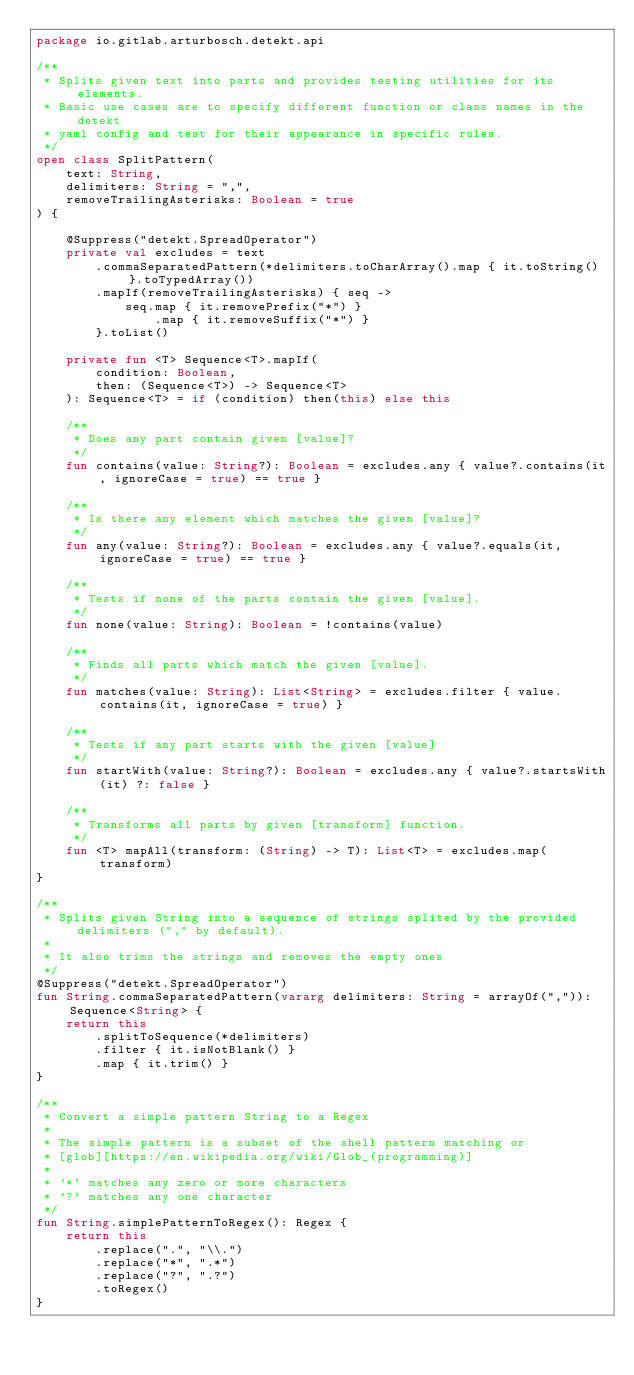Convert code to text. <code><loc_0><loc_0><loc_500><loc_500><_Kotlin_>package io.gitlab.arturbosch.detekt.api

/**
 * Splits given text into parts and provides testing utilities for its elements.
 * Basic use cases are to specify different function or class names in the detekt
 * yaml config and test for their appearance in specific rules.
 */
open class SplitPattern(
    text: String,
    delimiters: String = ",",
    removeTrailingAsterisks: Boolean = true
) {

    @Suppress("detekt.SpreadOperator")
    private val excludes = text
        .commaSeparatedPattern(*delimiters.toCharArray().map { it.toString() }.toTypedArray())
        .mapIf(removeTrailingAsterisks) { seq ->
            seq.map { it.removePrefix("*") }
                .map { it.removeSuffix("*") }
        }.toList()

    private fun <T> Sequence<T>.mapIf(
        condition: Boolean,
        then: (Sequence<T>) -> Sequence<T>
    ): Sequence<T> = if (condition) then(this) else this

    /**
     * Does any part contain given [value]?
     */
    fun contains(value: String?): Boolean = excludes.any { value?.contains(it, ignoreCase = true) == true }

    /**
     * Is there any element which matches the given [value]?
     */
    fun any(value: String?): Boolean = excludes.any { value?.equals(it, ignoreCase = true) == true }

    /**
     * Tests if none of the parts contain the given [value].
     */
    fun none(value: String): Boolean = !contains(value)

    /**
     * Finds all parts which match the given [value].
     */
    fun matches(value: String): List<String> = excludes.filter { value.contains(it, ignoreCase = true) }

    /**
     * Tests if any part starts with the given [value]
     */
    fun startWith(value: String?): Boolean = excludes.any { value?.startsWith(it) ?: false }

    /**
     * Transforms all parts by given [transform] function.
     */
    fun <T> mapAll(transform: (String) -> T): List<T> = excludes.map(transform)
}

/**
 * Splits given String into a sequence of strings splited by the provided delimiters ("," by default).
 *
 * It also trims the strings and removes the empty ones
 */
@Suppress("detekt.SpreadOperator")
fun String.commaSeparatedPattern(vararg delimiters: String = arrayOf(",")): Sequence<String> {
    return this
        .splitToSequence(*delimiters)
        .filter { it.isNotBlank() }
        .map { it.trim() }
}

/**
 * Convert a simple pattern String to a Regex
 *
 * The simple pattern is a subset of the shell pattern matching or
 * [glob][https://en.wikipedia.org/wiki/Glob_(programming)]
 *
 * '*' matches any zero or more characters
 * '?' matches any one character
 */
fun String.simplePatternToRegex(): Regex {
    return this
        .replace(".", "\\.")
        .replace("*", ".*")
        .replace("?", ".?")
        .toRegex()
}
</code> 